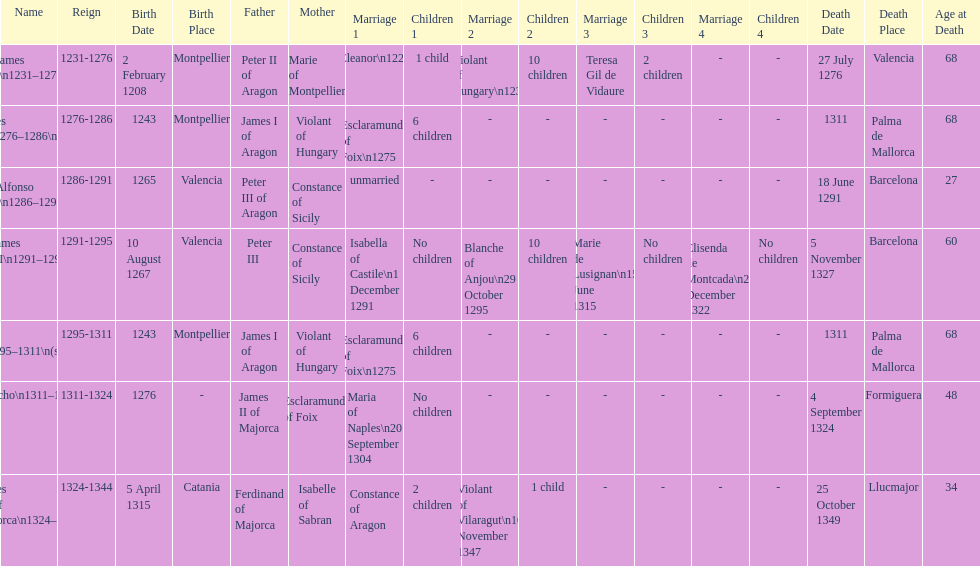Which monarch is listed first? James I 1231-1276. 